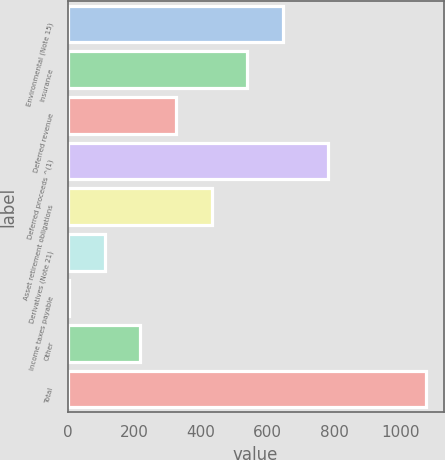Convert chart to OTSL. <chart><loc_0><loc_0><loc_500><loc_500><bar_chart><fcel>Environmental (Note 15)<fcel>Insurance<fcel>Deferred revenue<fcel>Deferred proceeds ^(1)<fcel>Asset retirement obligations<fcel>Derivatives (Note 21)<fcel>Income taxes payable<fcel>Other<fcel>Total<nl><fcel>646.6<fcel>539.5<fcel>325.3<fcel>781<fcel>432.4<fcel>111.1<fcel>4<fcel>218.2<fcel>1075<nl></chart> 